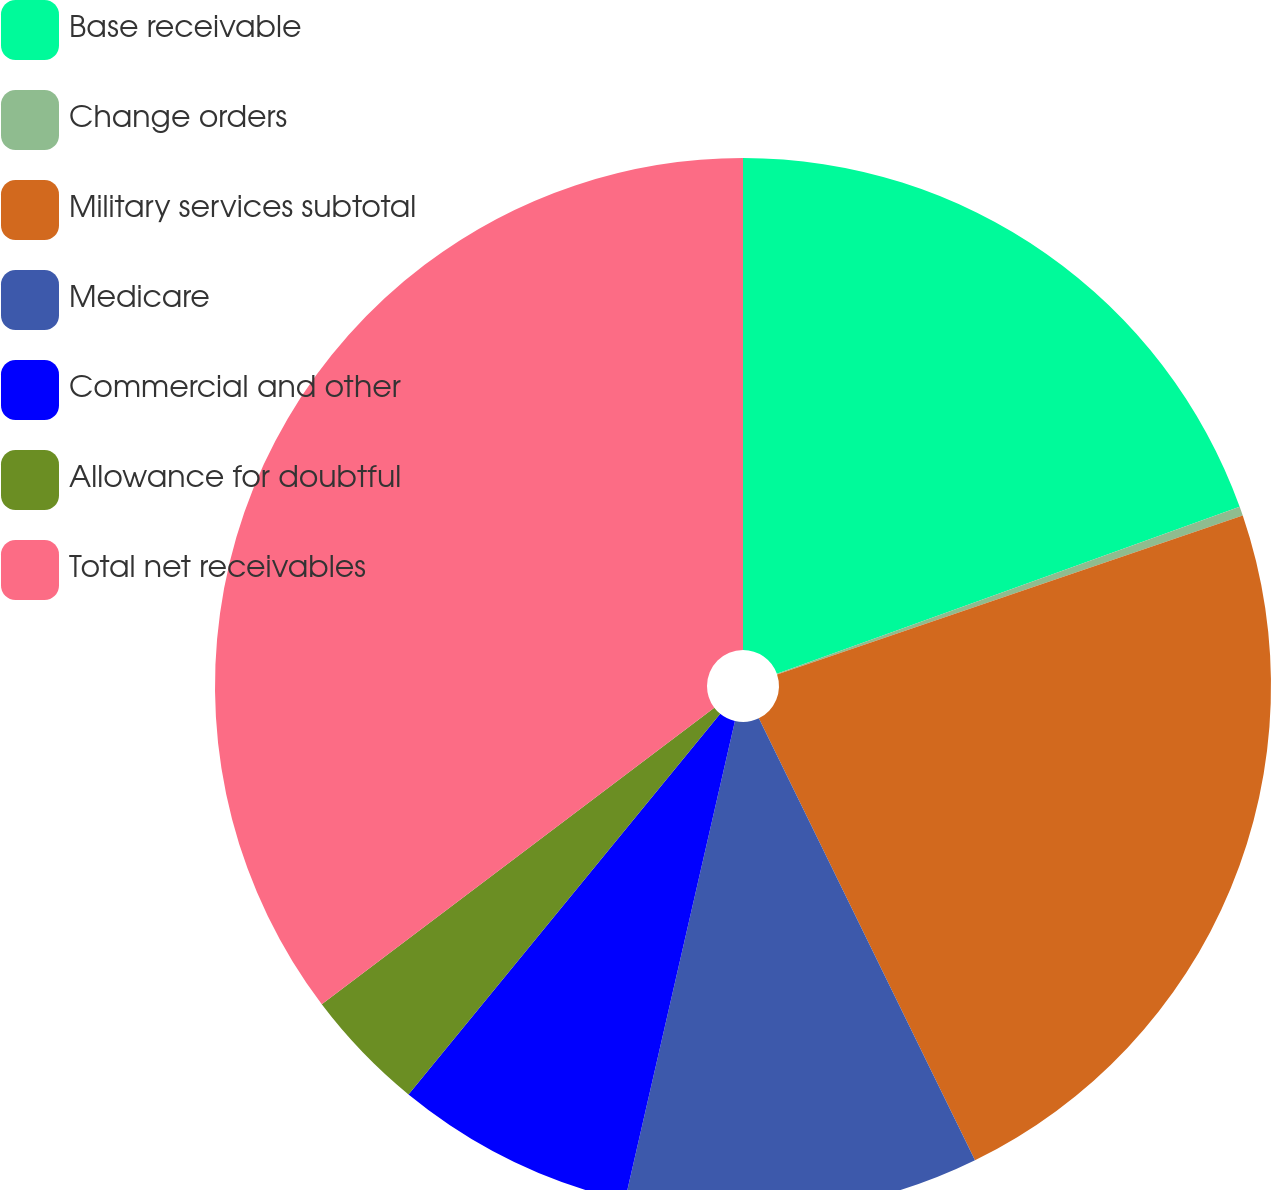<chart> <loc_0><loc_0><loc_500><loc_500><pie_chart><fcel>Base receivable<fcel>Change orders<fcel>Military services subtotal<fcel>Medicare<fcel>Commercial and other<fcel>Allowance for doubtful<fcel>Total net receivables<nl><fcel>19.49%<fcel>0.28%<fcel>22.99%<fcel>10.83%<fcel>7.33%<fcel>3.78%<fcel>35.3%<nl></chart> 